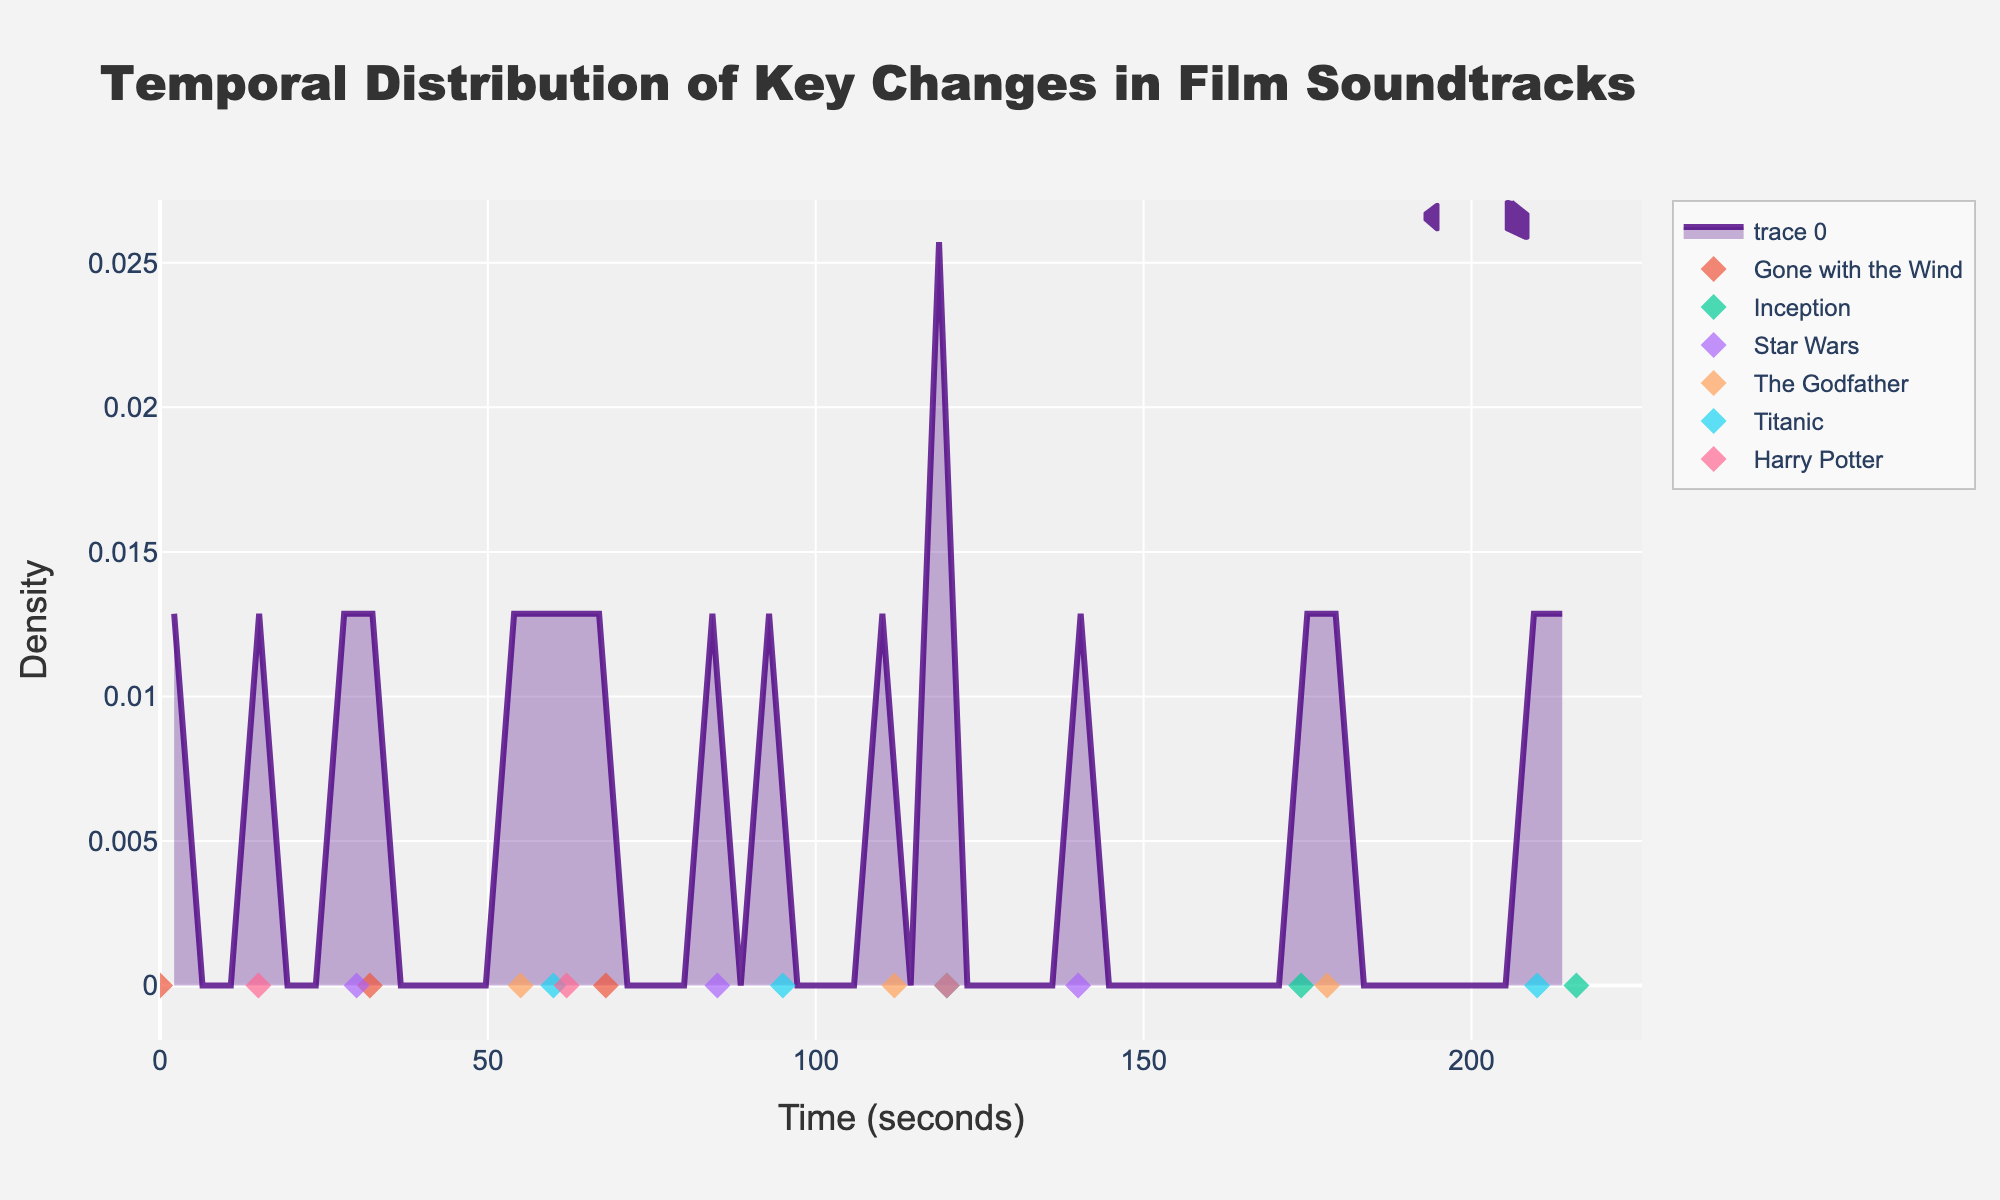How many key changes are recorded for each film? Count the number of points for each film in the plot: Gone with the Wind (3 points), Inception (3 points), Star Wars (3 points), The Godfather (3 points), Titanic (3 points), and Harry Potter (3 points).
Answer: 3 key changes each What is the range of timestamps covered in the plot? Look at the x-axis to see the range of timestamps; the plot starts at 0 seconds and ends a little above 210 seconds.
Answer: 0 to approximately 220 seconds Which film has the earliest key change? Identify the point with the lowest timestamp on the x-axis and check the legend for the corresponding film. There's a key change at 0 seconds for "Gone with the Wind".
Answer: Gone with the Wind At what time do "Inception" and "The Godfather" have their second key changes? Find the second marker for each film: "Inception" has its second key change at 174 seconds and "The Godfather" has its second key change at 112 seconds.
Answer: 174 seconds for "Inception", 112 seconds for "The Godfather" Which film has the highest density of key changes, and around what time period does this occur? Examine the density curve and find the peak. Note which film's points are closest to this peak. The density is highest around 110-120 seconds, shared by key changes from "The Godfather" and "Harry Potter".
Answer: The Godfather and Harry Potter, around 110-120 seconds Are there any films that have their key changes evenly spread throughout the timeline? Check if the markers for any film are evenly distributed across the x-axis: "Gone with the Wind" has key changes at 0, 32, and 68 seconds, which seem fairly evenly spread.
Answer: Gone with the Wind Is there any overlap in key change times between "Star Wars" and another film? If so, which films and when? Look for any similar timestamps between "Star Wars" and other films: "Star Wars" has a key change at 30 seconds, and "Gone with the Wind" has one at 32 seconds. However, they're not exactly overlapping.
Answer: No exact overlap Does the density plot show a secondary peak? If so, around what time? Look at the density curve to see if there's another noticeable peak: there's a secondary peak around 60-70 seconds.
Answer: Around 60-70 seconds How many musical note shapes are in the figure, and where are they positioned? Count the musical note shapes and note their positions. The shapes are at top-right corners, with two shapes positioned close to each other.
Answer: 2 shapes, top-right corner Which film has the most key changes in the second half of the timeline (after 110 seconds)? Identify the points for each film after 110 on the x-axis: "Inception", "The Godfather", and "Titanic" each have key changes after 110 seconds. "Inception" has two key changes, while "The Godfather" and "Titanic" have one each.
Answer: Inception 